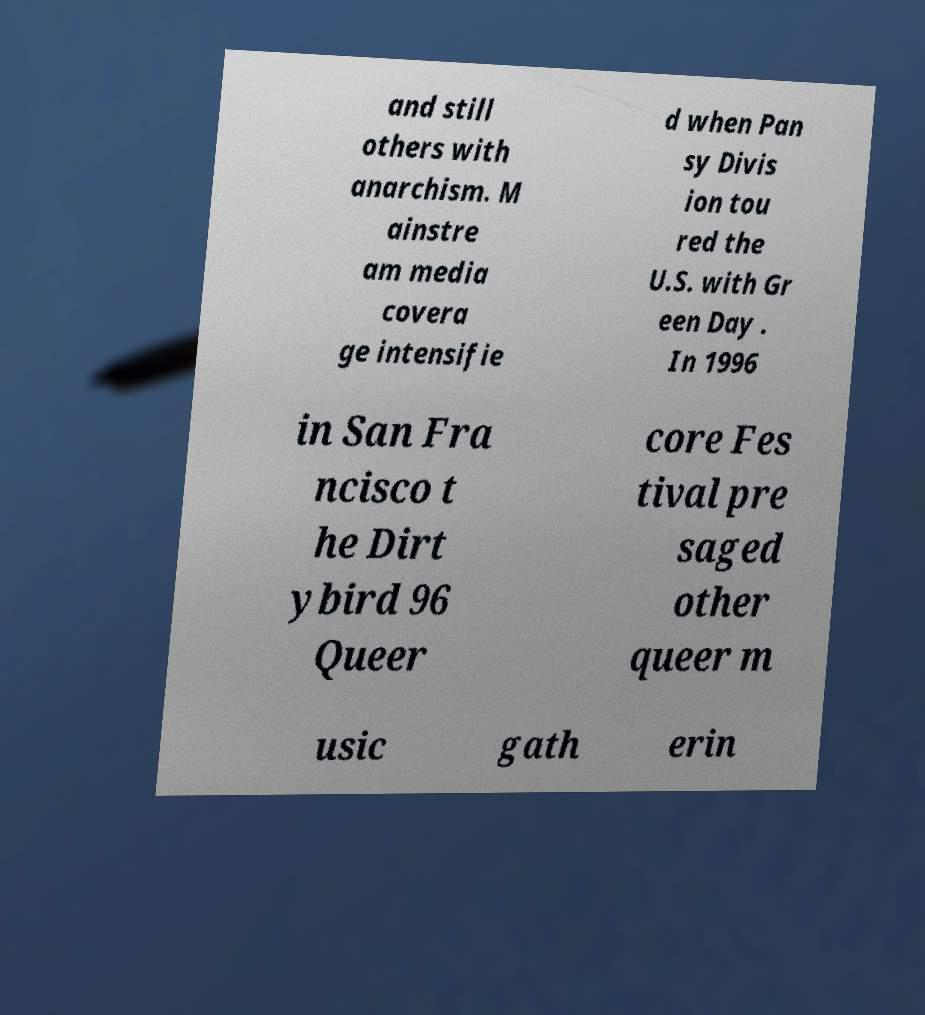Could you extract and type out the text from this image? and still others with anarchism. M ainstre am media covera ge intensifie d when Pan sy Divis ion tou red the U.S. with Gr een Day . In 1996 in San Fra ncisco t he Dirt ybird 96 Queer core Fes tival pre saged other queer m usic gath erin 